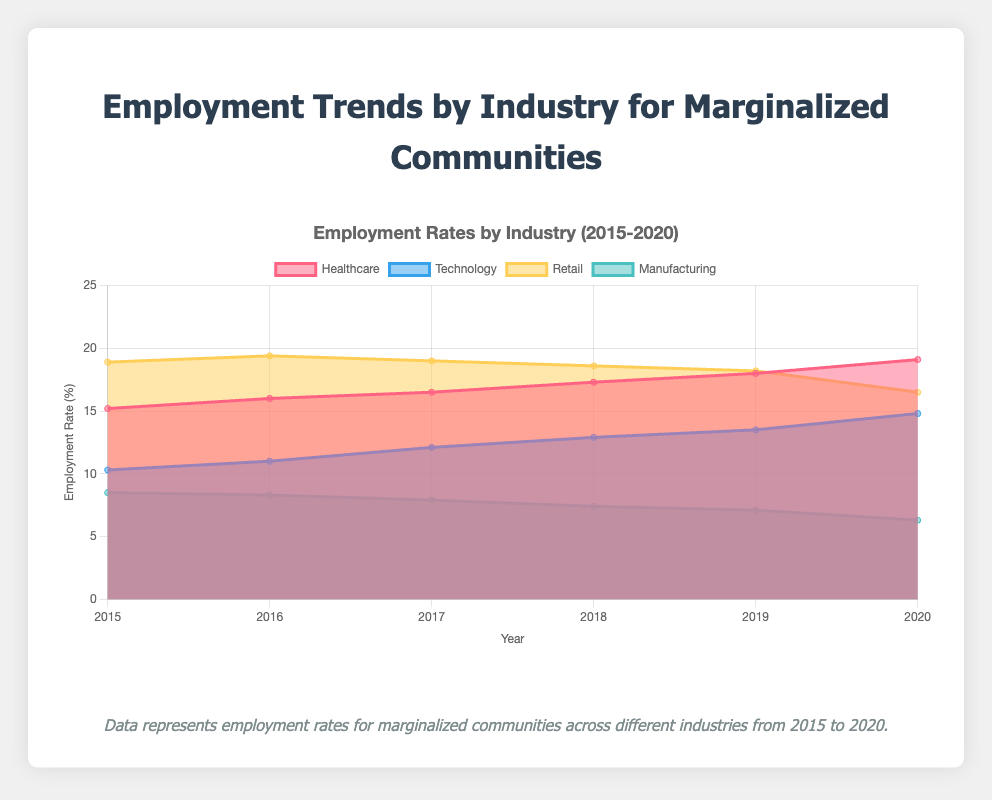What is the title of the chart? The title is displayed at the top of the chart and reads "Employment Trends by Industry for Marginalized Communities".
Answer: Employment Trends by Industry for Marginalized Communities Which industry had the highest employment rate in 2020? By looking at the chart for the year 2020, the color representing Healthcare has the highest position on the vertical axis.
Answer: Healthcare What is the employment rate trend for the Manufacturing industry from 2015 to 2020? Observing the line representing Manufacturing from 2015 to 2020, the line is consistently trending downwards.
Answer: Decreasing Between which years did the Retail industry see the largest drop in employment rate? By comparing the slopes of the line representing the Retail industry, the largest drop appears between 2019 and 2020.
Answer: 2019-2020 Which industry experienced a steady increase in employment rates without any decrease from 2015 to 2020? By looking for a line that only trends upward without any dips, the Technology industry shows a consistent rise in employment rates.
Answer: Technology What is the average employment rate for the Healthcare industry from 2015 to 2020? Adding the employment rates for Healthcare (15.2, 16.0, 16.5, 17.3, 18.0, 19.1) and dividing by the number of years (6) gives (15.2 + 16.0 + 16.5 + 17.3 + 18.0 + 19.1) / 6 = 17.35.
Answer: 17.35 How much did the employment rate for the Technology industry increase from 2015 to 2020? Subtracting Technology's employment rate in 2015 (10.3) from its rate in 2020 (14.8) gives 14.8 - 10.3 = 4.5.
Answer: 4.5 In which year did the Manufacturing industry have the lowest employment rate? The chart shows the Manufacturing industry's lowest employment rate in 2020 at 6.3%.
Answer: 2020 Compare the employment rates of the Retail and Technology industries in 2017. Which one had a higher rate and by how much? In 2017, the Retail industry had an employment rate of 19.0%, and Technology had 12.1%. The difference is 19.0 - 12.1 = 6.9%.
Answer: Retail by 6.9% What pattern do you observe in the employment rate of the Retail industry from 2015 to 2020? Observing the chart, Retail employment rate increased slightly from 2015 to 2016, peaked, and then decreased with some fluctuations until 2020.
Answer: Increase then decrease 